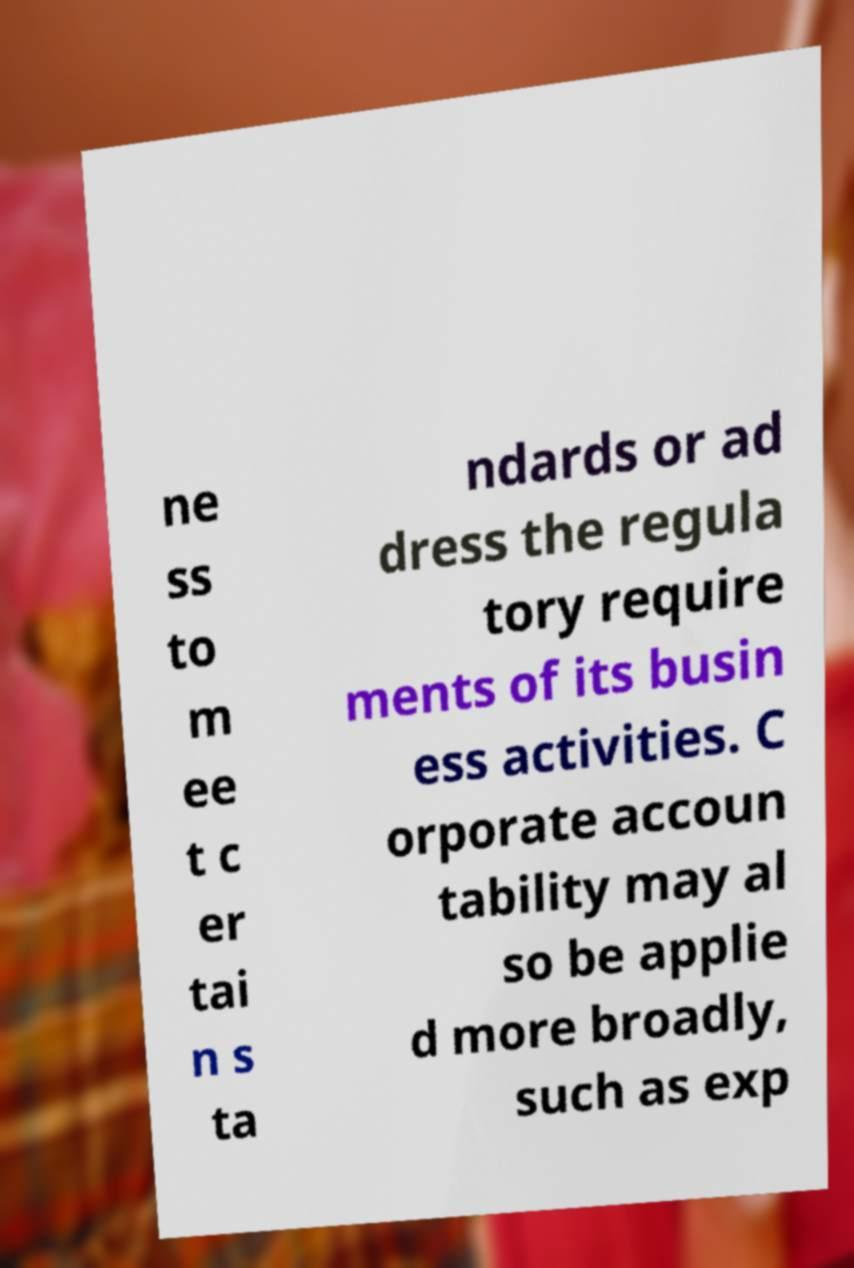Could you assist in decoding the text presented in this image and type it out clearly? ne ss to m ee t c er tai n s ta ndards or ad dress the regula tory require ments of its busin ess activities. C orporate accoun tability may al so be applie d more broadly, such as exp 